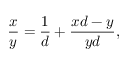<formula> <loc_0><loc_0><loc_500><loc_500>{ \frac { x } { y } } = { \frac { 1 } { d } } + { \frac { x d - y } { y d } } ,</formula> 